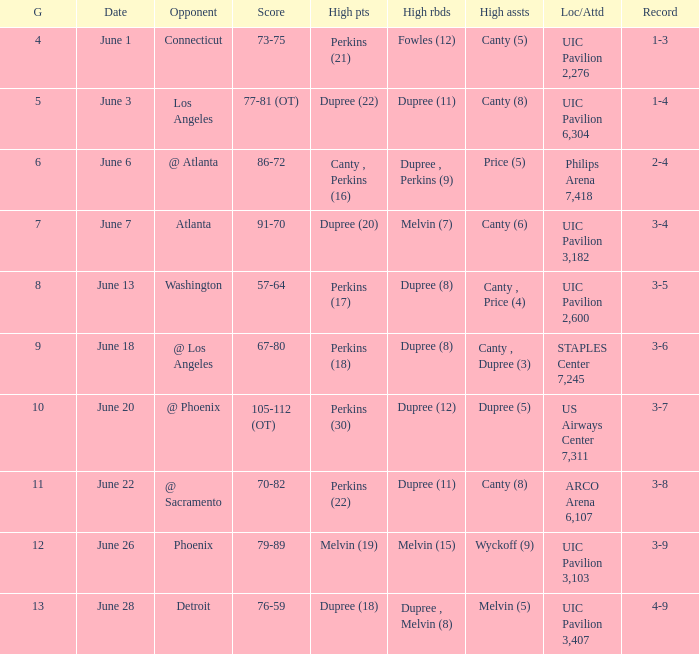Who had the most assists in the game that led to a 3-7 record? Dupree (5). 